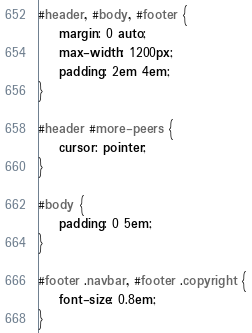<code> <loc_0><loc_0><loc_500><loc_500><_CSS_>#header, #body, #footer {
	margin: 0 auto;
	max-width: 1200px;
	padding: 2em 4em;
}

#header #more-peers {
	cursor: pointer;
}

#body {
	padding: 0 5em;
}

#footer .navbar, #footer .copyright {
	font-size: 0.8em;
}</code> 